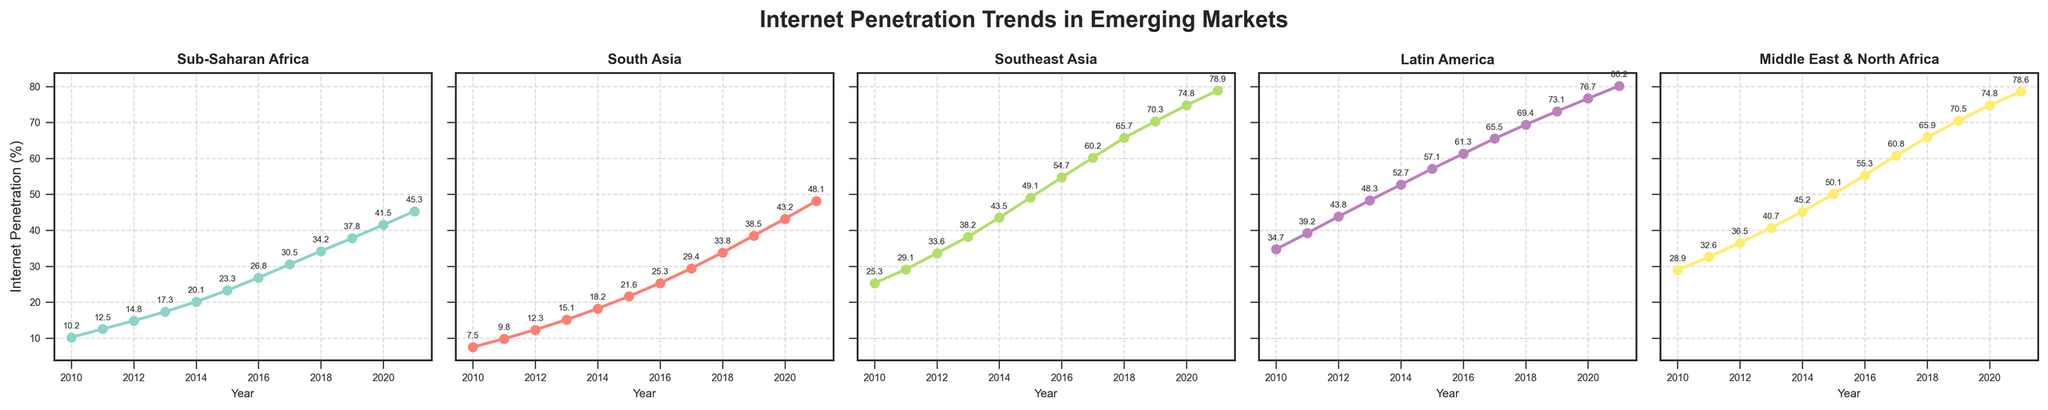What year did Southeast Asia reach an internet penetration of over 50%? Look at the plot for Southeast Asia and identify the first year where the penetration is above 50%.
Answer: 2015 Which region had the highest internet penetration in 2012? Compare the data points for all regions in 2012 and identify which is the highest.
Answer: Latin America By how much did internet penetration in South Asia increase from 2010 to 2021? Refer to the plot of South Asia, subtract the 2010 value from the 2021 value (48.1 - 7.5).
Answer: 40.6 What is the average internet penetration in Sub-Saharan Africa over the years presented? Sum up the values for Sub-Saharan Africa from 2010 to 2021 and then divide by the number of years (12).
Answer: 26.55 Which region experienced the steepest increase in internet penetration between 2016 and 2017? Compare the differences in values for each region between 2016 and 2017, and identify which one is the highest.
Answer: Southeast Asia Between 2011 and 2014, which region had the largest percentage point increase in internet penetration? Calculate the difference between the 2011 and 2014 values for each region and find the largest difference.
Answer: Southeast Asia What percentage point increase did the Middle East & North Africa see from 2015 to 2020? Subtract the 2015 value from the 2020 value for the Middle East & North Africa (74.8 - 50.1).
Answer: 24.7 In which year did Latin America surpass 70% internet penetration? Identify the year in the Latin America plot where the dots are first above 70%.
Answer: 2019 What is the median internet penetration for Southeast Asia for the years shown? List the values for Southeast Asia, sort them, and find the middle value in this ordered set. If a dataset has an even number of observations, the median is the average of the two middle numbers.
Answer: 54.7 Compare the internet penetration growth between Sub-Saharan Africa and South Asia from 2010 to 2021. Which region had a higher growth? Calculate the differences from 2010 to 2021 for both regions and compare them (Sub-Saharan Africa: 45.3 - 10.2, South Asia: 48.1 - 7.5).
Answer: South Asia 